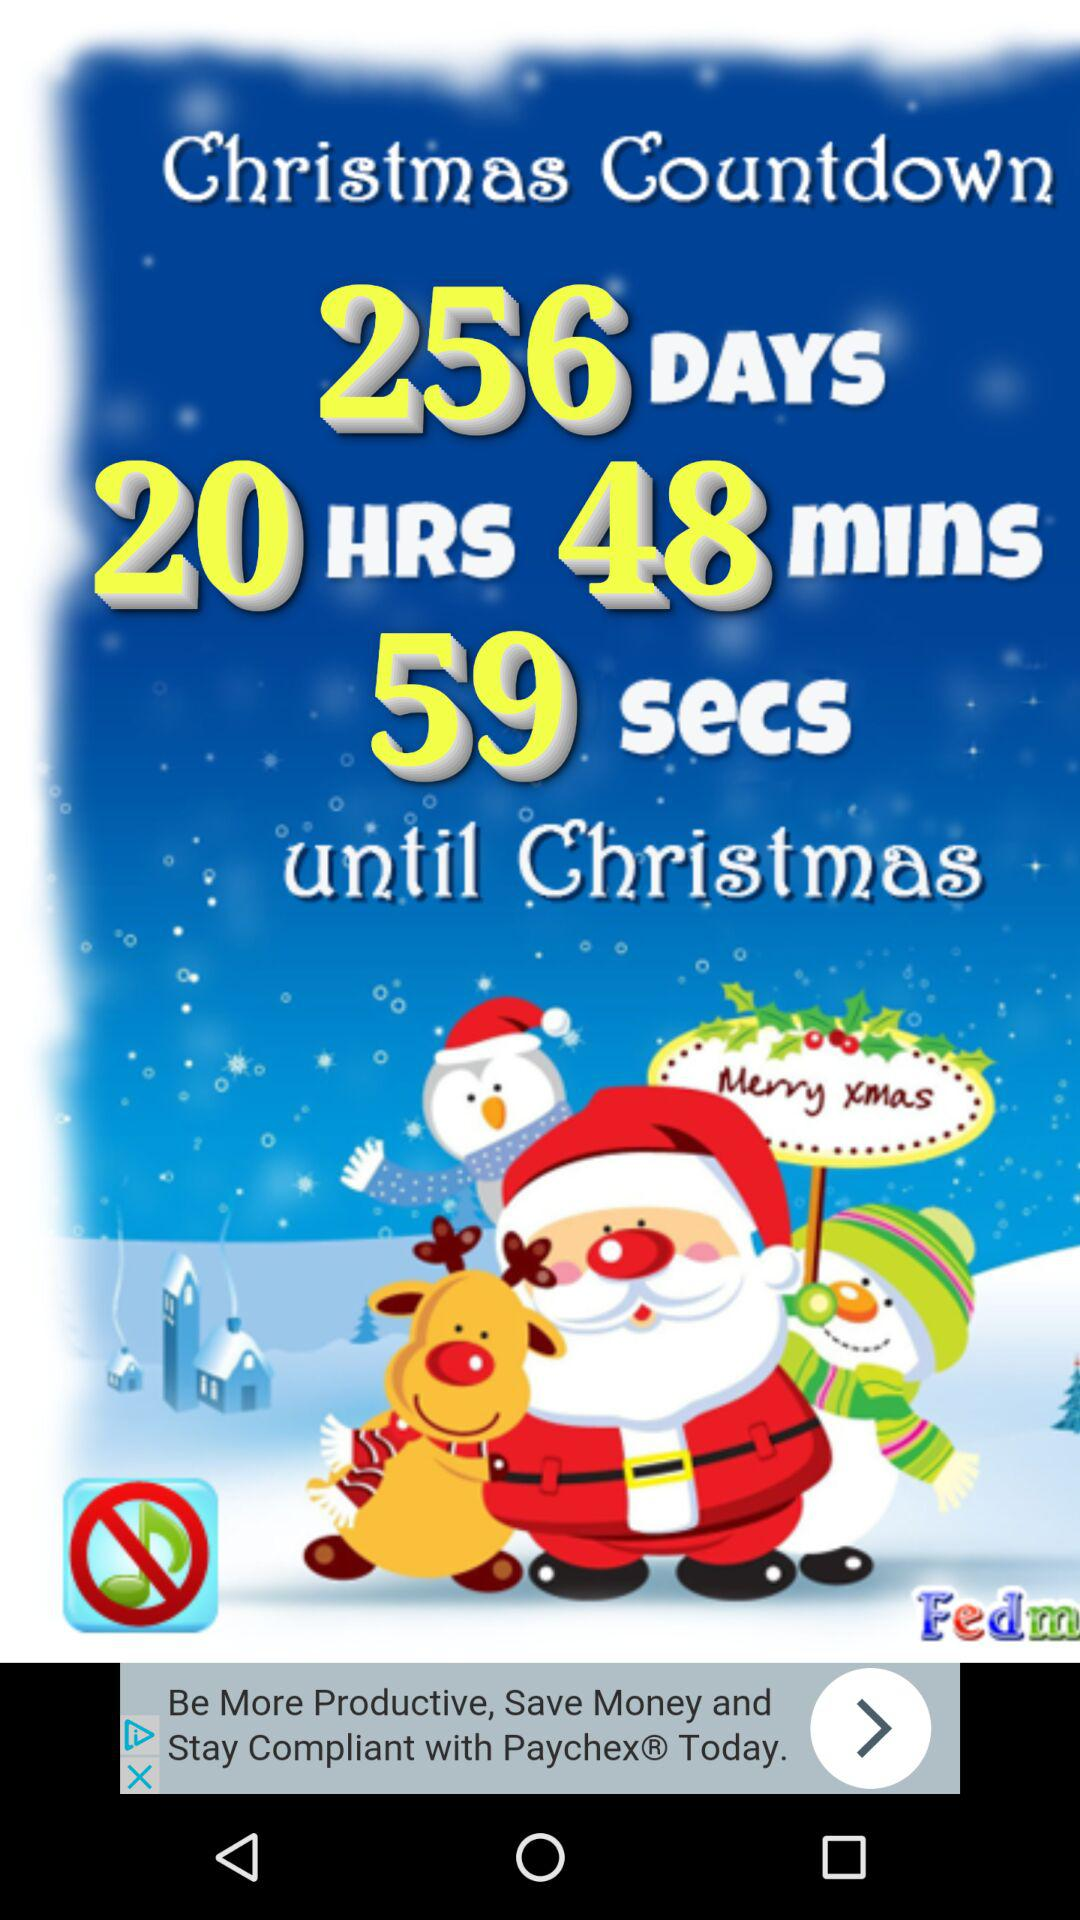What's the Christmas countdown until Christmas? The Christmas countdown until Christmas is 256 days, 20 hours, 48 minutes and 59 seconds. 